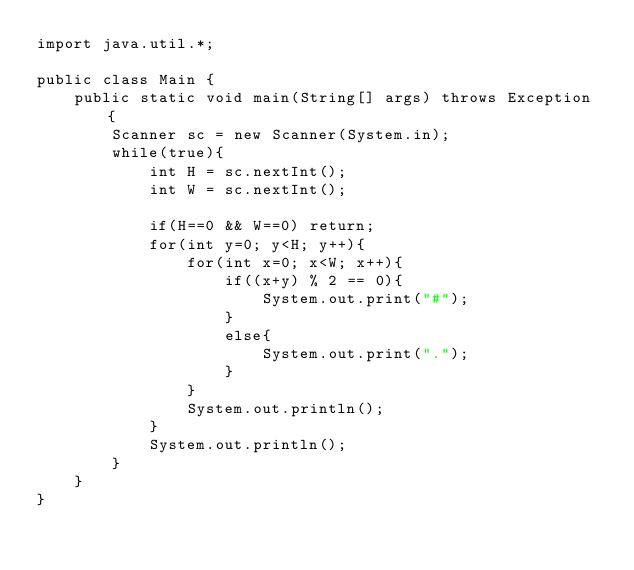Convert code to text. <code><loc_0><loc_0><loc_500><loc_500><_Java_>import java.util.*;

public class Main {
    public static void main(String[] args) throws Exception {
        Scanner sc = new Scanner(System.in);
        while(true){
            int H = sc.nextInt();
            int W = sc.nextInt();
            
            if(H==0 && W==0) return;
            for(int y=0; y<H; y++){
                for(int x=0; x<W; x++){
                    if((x+y) % 2 == 0){
                        System.out.print("#");
                    }
                    else{
                        System.out.print(".");
                    }
                }
                System.out.println();
            }
            System.out.println();
        }
    }
}

</code> 